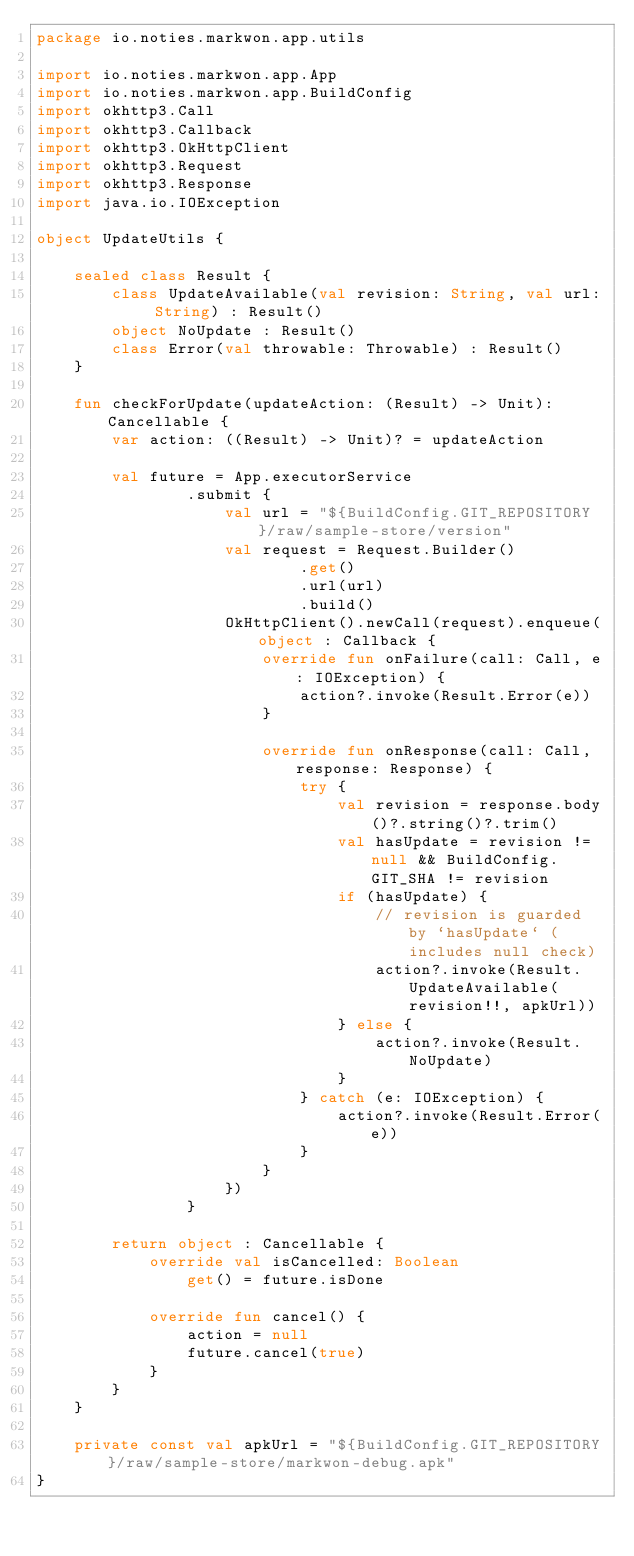<code> <loc_0><loc_0><loc_500><loc_500><_Kotlin_>package io.noties.markwon.app.utils

import io.noties.markwon.app.App
import io.noties.markwon.app.BuildConfig
import okhttp3.Call
import okhttp3.Callback
import okhttp3.OkHttpClient
import okhttp3.Request
import okhttp3.Response
import java.io.IOException

object UpdateUtils {

    sealed class Result {
        class UpdateAvailable(val revision: String, val url: String) : Result()
        object NoUpdate : Result()
        class Error(val throwable: Throwable) : Result()
    }

    fun checkForUpdate(updateAction: (Result) -> Unit): Cancellable {
        var action: ((Result) -> Unit)? = updateAction

        val future = App.executorService
                .submit {
                    val url = "${BuildConfig.GIT_REPOSITORY}/raw/sample-store/version"
                    val request = Request.Builder()
                            .get()
                            .url(url)
                            .build()
                    OkHttpClient().newCall(request).enqueue(object : Callback {
                        override fun onFailure(call: Call, e: IOException) {
                            action?.invoke(Result.Error(e))
                        }

                        override fun onResponse(call: Call, response: Response) {
                            try {
                                val revision = response.body()?.string()?.trim()
                                val hasUpdate = revision != null && BuildConfig.GIT_SHA != revision
                                if (hasUpdate) {
                                    // revision is guarded by `hasUpdate` (includes null check)
                                    action?.invoke(Result.UpdateAvailable(revision!!, apkUrl))
                                } else {
                                    action?.invoke(Result.NoUpdate)
                                }
                            } catch (e: IOException) {
                                action?.invoke(Result.Error(e))
                            }
                        }
                    })
                }

        return object : Cancellable {
            override val isCancelled: Boolean
                get() = future.isDone

            override fun cancel() {
                action = null
                future.cancel(true)
            }
        }
    }

    private const val apkUrl = "${BuildConfig.GIT_REPOSITORY}/raw/sample-store/markwon-debug.apk"
}</code> 